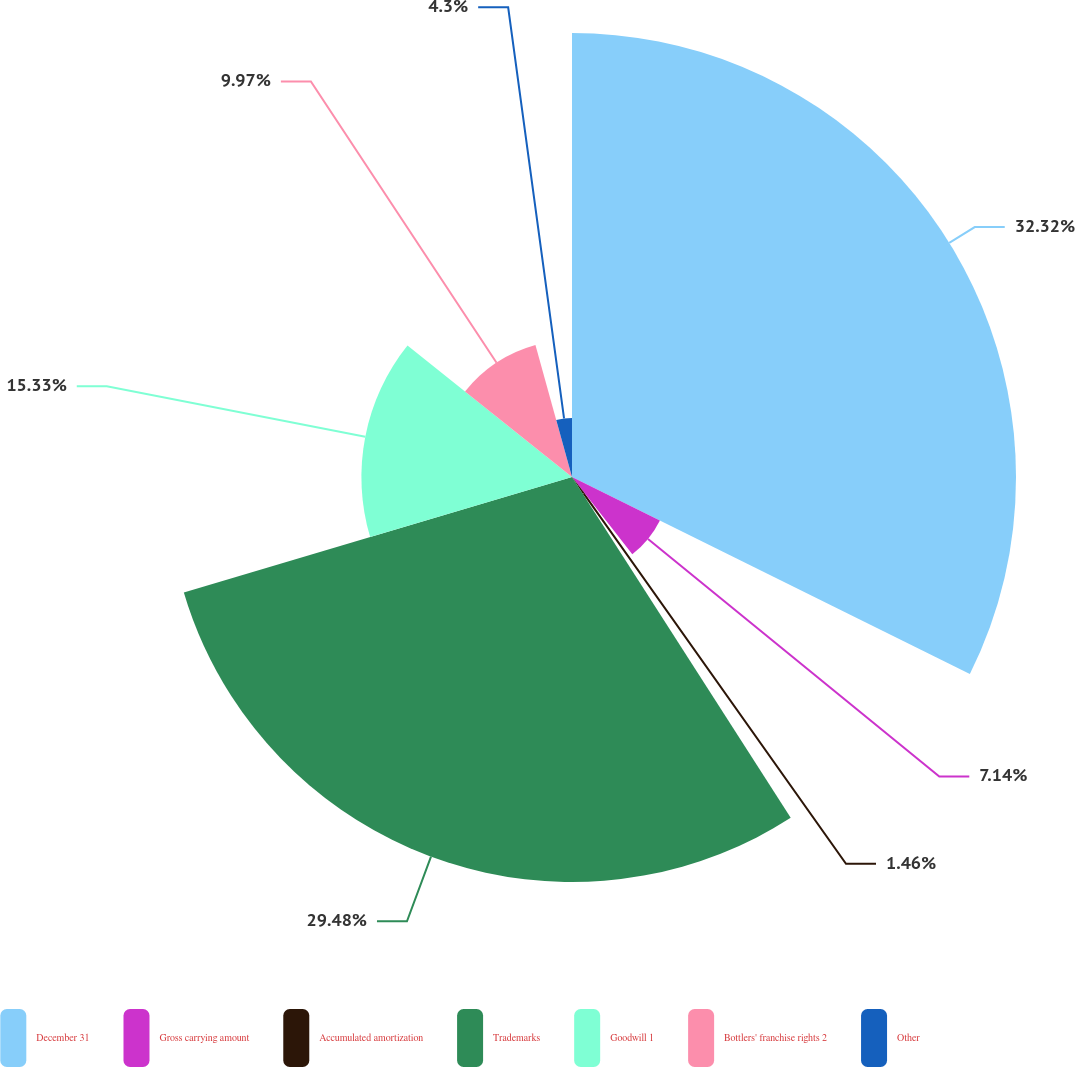<chart> <loc_0><loc_0><loc_500><loc_500><pie_chart><fcel>December 31<fcel>Gross carrying amount<fcel>Accumulated amortization<fcel>Trademarks<fcel>Goodwill 1<fcel>Bottlers' franchise rights 2<fcel>Other<nl><fcel>32.32%<fcel>7.14%<fcel>1.46%<fcel>29.48%<fcel>15.33%<fcel>9.97%<fcel>4.3%<nl></chart> 